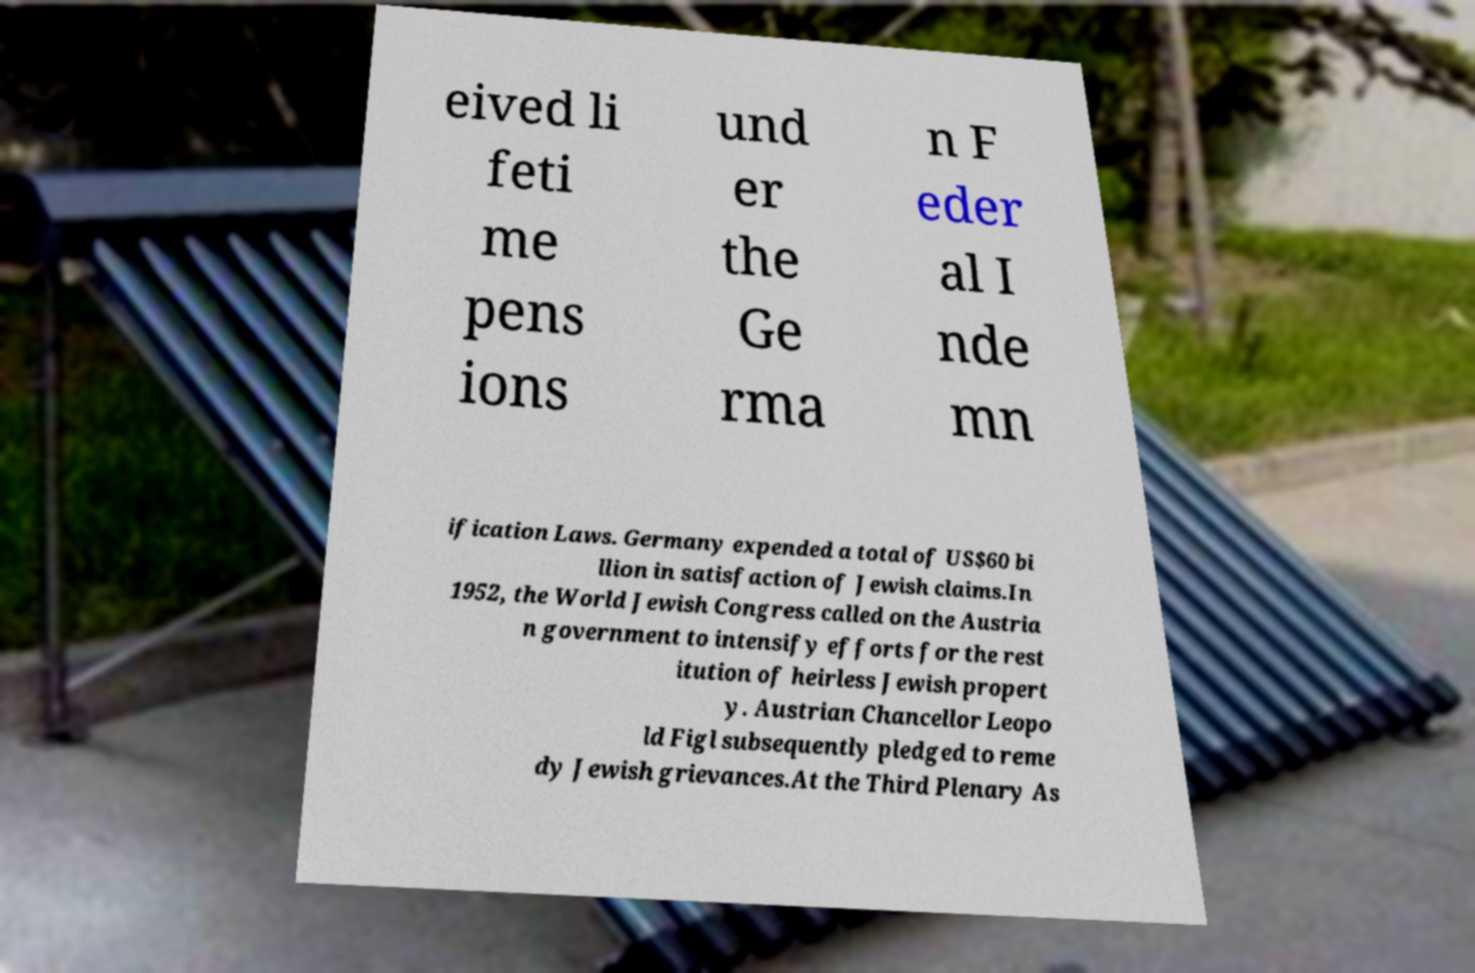I need the written content from this picture converted into text. Can you do that? eived li feti me pens ions und er the Ge rma n F eder al I nde mn ification Laws. Germany expended a total of US$60 bi llion in satisfaction of Jewish claims.In 1952, the World Jewish Congress called on the Austria n government to intensify efforts for the rest itution of heirless Jewish propert y. Austrian Chancellor Leopo ld Figl subsequently pledged to reme dy Jewish grievances.At the Third Plenary As 